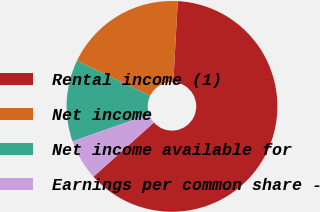Convert chart to OTSL. <chart><loc_0><loc_0><loc_500><loc_500><pie_chart><fcel>Rental income (1)<fcel>Net income<fcel>Net income available for<fcel>Earnings per common share -<nl><fcel>62.5%<fcel>18.75%<fcel>12.5%<fcel>6.25%<nl></chart> 